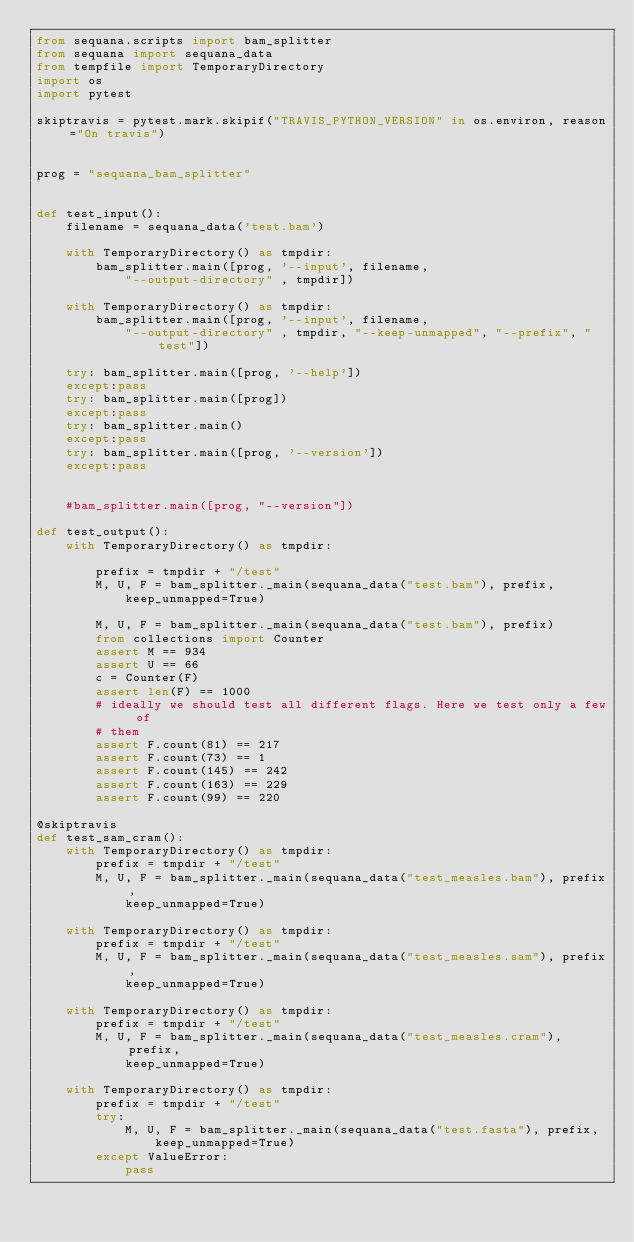<code> <loc_0><loc_0><loc_500><loc_500><_Python_>from sequana.scripts import bam_splitter
from sequana import sequana_data
from tempfile import TemporaryDirectory
import os
import pytest

skiptravis = pytest.mark.skipif("TRAVIS_PYTHON_VERSION" in os.environ, reason="On travis")


prog = "sequana_bam_splitter"


def test_input():
    filename = sequana_data('test.bam')

    with TemporaryDirectory() as tmpdir:
        bam_splitter.main([prog, '--input', filename,
            "--output-directory" , tmpdir])

    with TemporaryDirectory() as tmpdir:
        bam_splitter.main([prog, '--input', filename,
            "--output-directory" , tmpdir, "--keep-unmapped", "--prefix", "test"])

    try: bam_splitter.main([prog, '--help'])
    except:pass
    try: bam_splitter.main([prog])
    except:pass
    try: bam_splitter.main()
    except:pass
    try: bam_splitter.main([prog, '--version'])
    except:pass


    #bam_splitter.main([prog, "--version"])

def test_output():
    with TemporaryDirectory() as tmpdir:

        prefix = tmpdir + "/test"
        M, U, F = bam_splitter._main(sequana_data("test.bam"), prefix,
            keep_unmapped=True)

        M, U, F = bam_splitter._main(sequana_data("test.bam"), prefix)
        from collections import Counter
        assert M == 934
        assert U == 66
        c = Counter(F)
        assert len(F) == 1000
        # ideally we should test all different flags. Here we test only a few of
        # them
        assert F.count(81) == 217
        assert F.count(73) == 1
        assert F.count(145) == 242
        assert F.count(163) == 229
        assert F.count(99) == 220

@skiptravis
def test_sam_cram():
    with TemporaryDirectory() as tmpdir:
        prefix = tmpdir + "/test"
        M, U, F = bam_splitter._main(sequana_data("test_measles.bam"), prefix,
            keep_unmapped=True)

    with TemporaryDirectory() as tmpdir:
        prefix = tmpdir + "/test"
        M, U, F = bam_splitter._main(sequana_data("test_measles.sam"), prefix,
            keep_unmapped=True)

    with TemporaryDirectory() as tmpdir:
        prefix = tmpdir + "/test"
        M, U, F = bam_splitter._main(sequana_data("test_measles.cram"), prefix,
            keep_unmapped=True)

    with TemporaryDirectory() as tmpdir:
        prefix = tmpdir + "/test"
        try:
            M, U, F = bam_splitter._main(sequana_data("test.fasta"), prefix,
                keep_unmapped=True)
        except ValueError:
            pass










</code> 